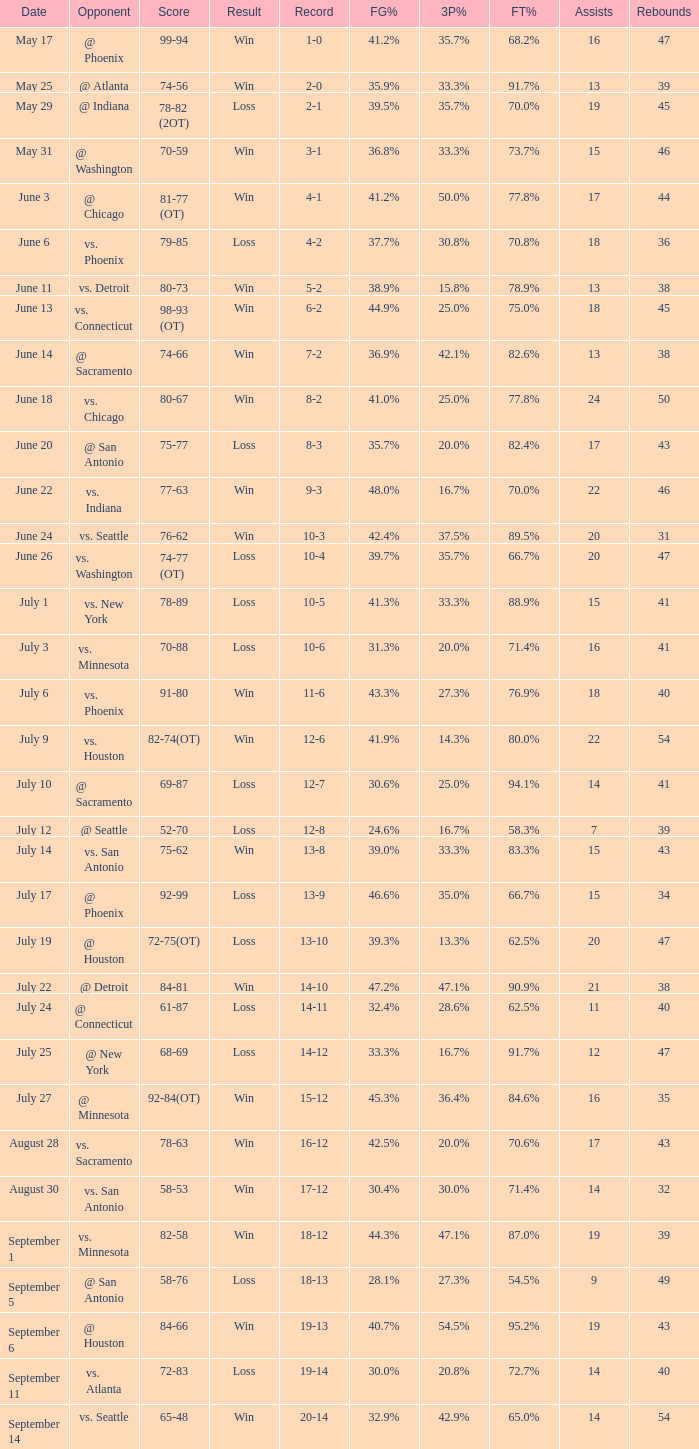What is the Score of the game @ San Antonio on June 20? 75-77. 